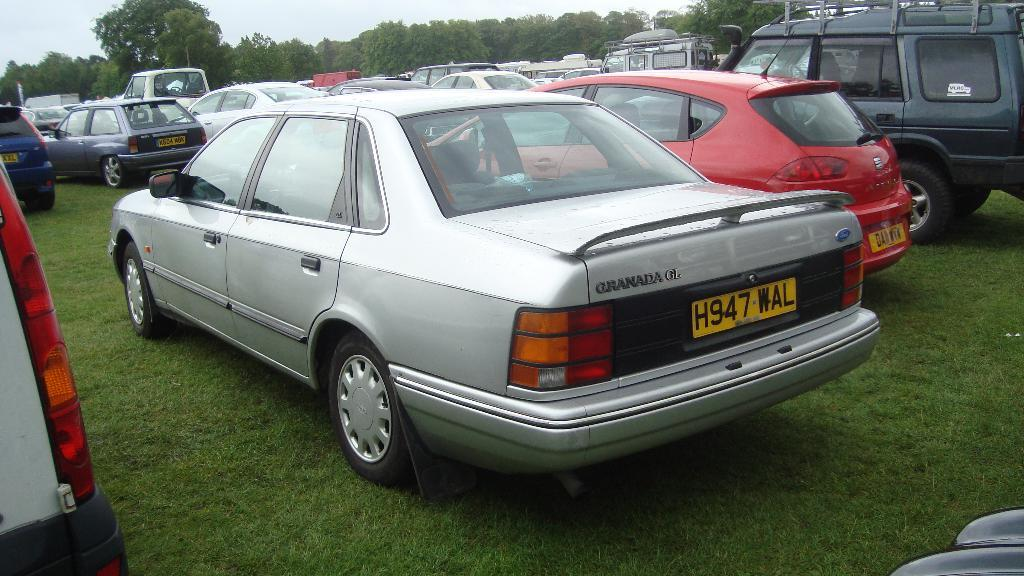What types of objects are present in the image? There are vehicles in the image. What natural elements can be seen in the image? There are trees and grass in the image. How many parcels are being delivered by the vehicles in the image? There is no information about parcels or deliveries in the image; it only shows vehicles, trees, and grass. 